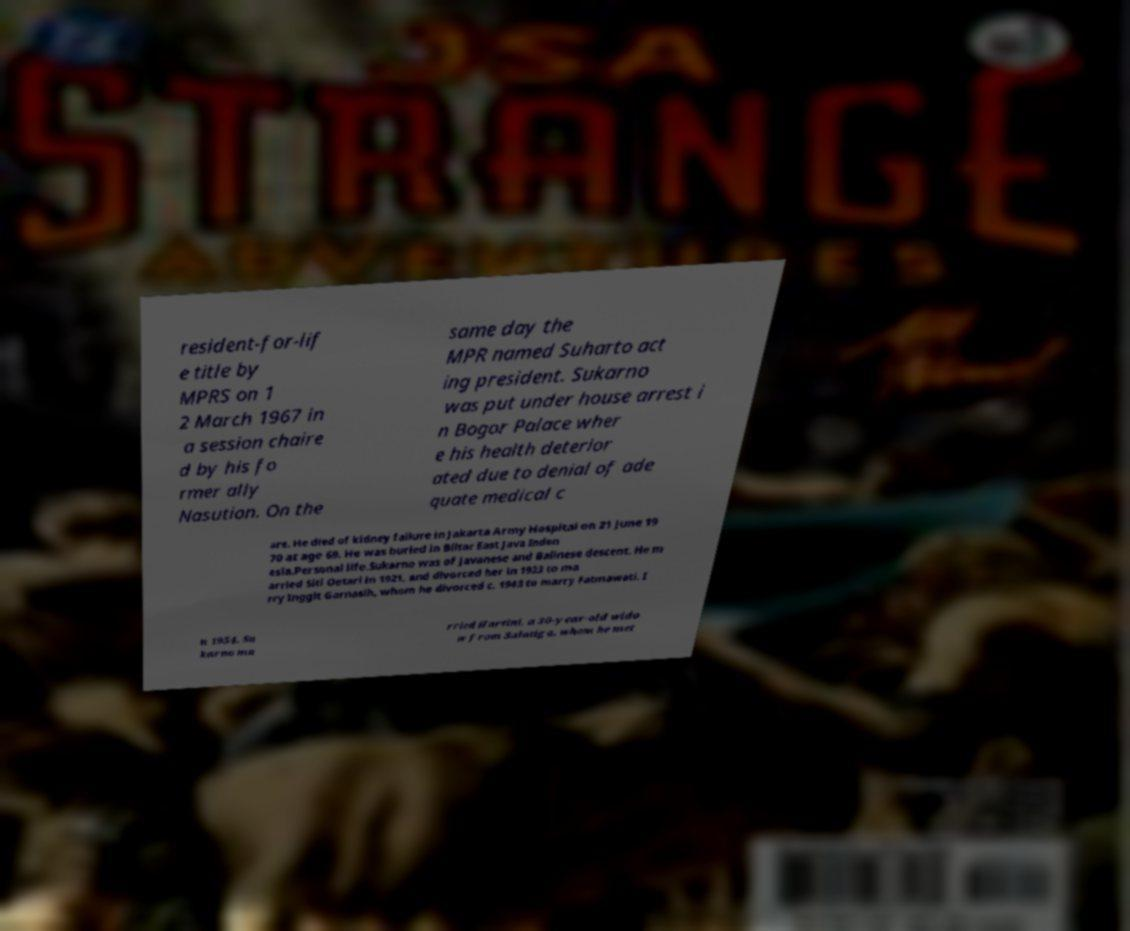Please read and relay the text visible in this image. What does it say? resident-for-lif e title by MPRS on 1 2 March 1967 in a session chaire d by his fo rmer ally Nasution. On the same day the MPR named Suharto act ing president. Sukarno was put under house arrest i n Bogor Palace wher e his health deterior ated due to denial of ade quate medical c are. He died of kidney failure in Jakarta Army Hospital on 21 June 19 70 at age 69. He was buried in Blitar East Java Indon esia.Personal life.Sukarno was of Javanese and Balinese descent. He m arried Siti Oetari in 1921, and divorced her in 1923 to ma rry Inggit Garnasih, whom he divorced c. 1943 to marry Fatmawati. I n 1954, Su karno ma rried Hartini, a 30-year-old wido w from Salatiga, whom he met 